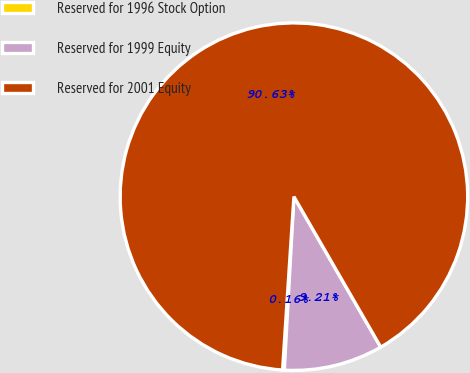<chart> <loc_0><loc_0><loc_500><loc_500><pie_chart><fcel>Reserved for 1996 Stock Option<fcel>Reserved for 1999 Equity<fcel>Reserved for 2001 Equity<nl><fcel>0.16%<fcel>9.21%<fcel>90.63%<nl></chart> 